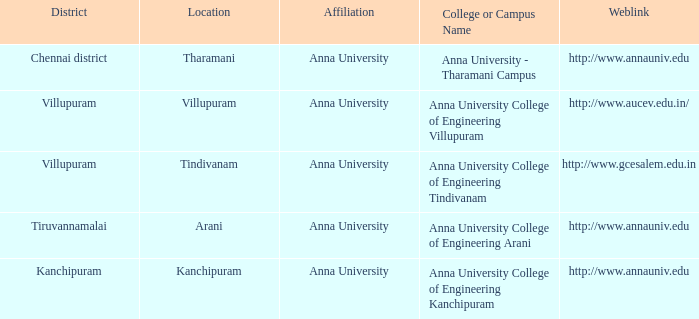In what location can one find a college or campus named anna university - tharamani campus? Tharamani. 